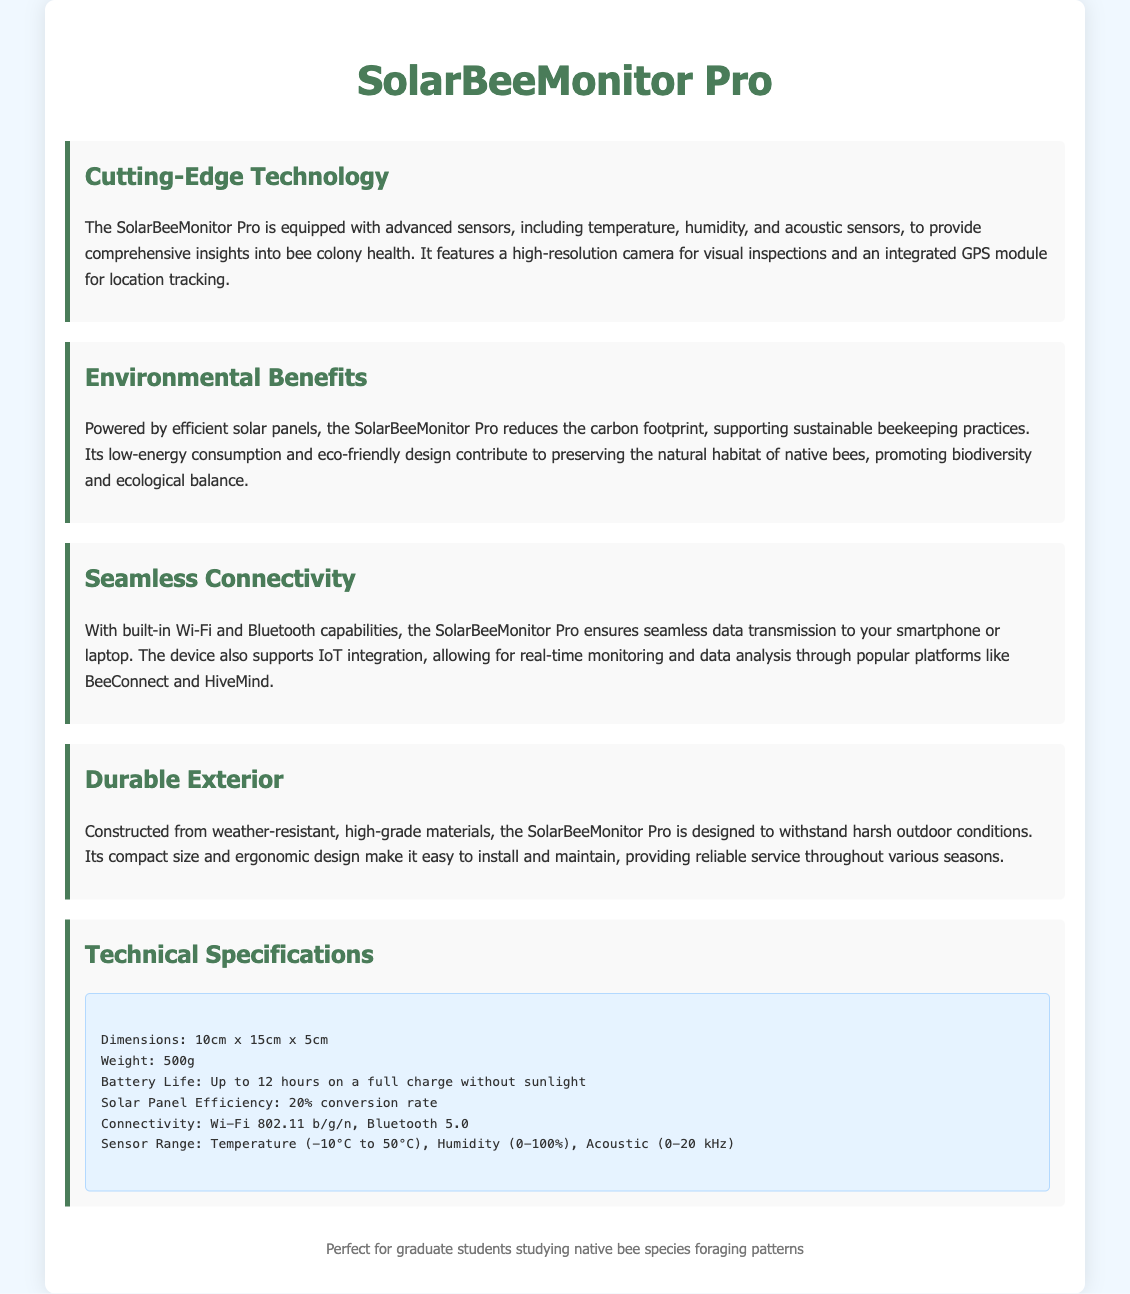what sensors are included in the device? The document states that the device includes temperature, humidity, and acoustic sensors.
Answer: temperature, humidity, and acoustic sensors what is the solar panel efficiency? The efficiency of the solar panel is mentioned in the technical specifications as a conversion rate.
Answer: 20% conversion rate what is the weight of the SolarBeeMonitor Pro? The weight is specified in the technical specifications section of the document.
Answer: 500g how long can the battery last on a full charge without sunlight? The document provides information about the battery life when fully charged and without sunlight.
Answer: Up to 12 hours what supports real-time monitoring and data analysis? The device supports IoT integration allowing for real-time monitoring and data analysis.
Answer: IoT integration 